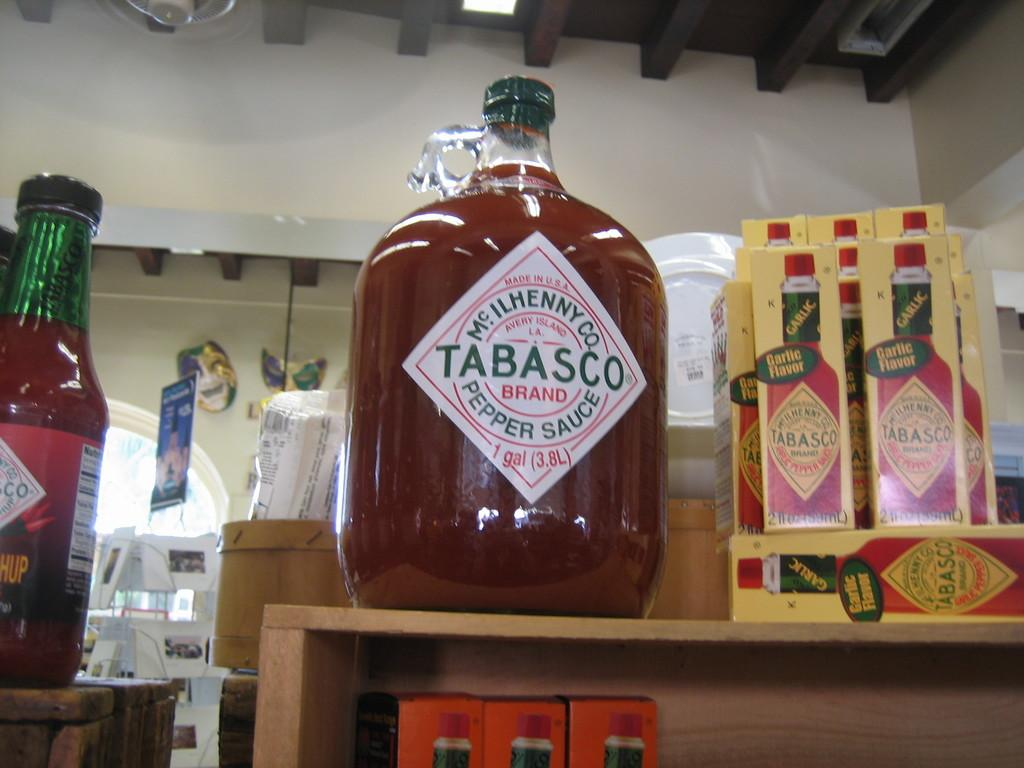<image>
Write a terse but informative summary of the picture. Different flavors of Tabasco sauce sit on some shelves. 